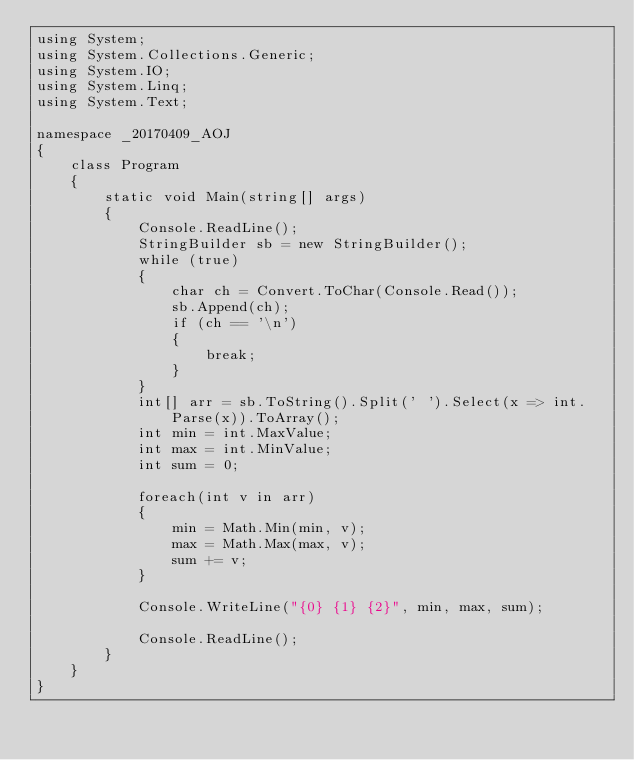<code> <loc_0><loc_0><loc_500><loc_500><_C#_>using System;
using System.Collections.Generic;
using System.IO;
using System.Linq;
using System.Text;

namespace _20170409_AOJ
{
    class Program
    {
        static void Main(string[] args)
        {
            Console.ReadLine();
            StringBuilder sb = new StringBuilder();
            while (true)
            {
                char ch = Convert.ToChar(Console.Read());
                sb.Append(ch);
                if (ch == '\n')
                {
                    break;
                }
            }
            int[] arr = sb.ToString().Split(' ').Select(x => int.Parse(x)).ToArray();
            int min = int.MaxValue;
            int max = int.MinValue;
            int sum = 0;
            
            foreach(int v in arr)
            {
                min = Math.Min(min, v);
                max = Math.Max(max, v);
                sum += v;
            }

            Console.WriteLine("{0} {1} {2}", min, max, sum);

            Console.ReadLine();
        }
    }
}</code> 